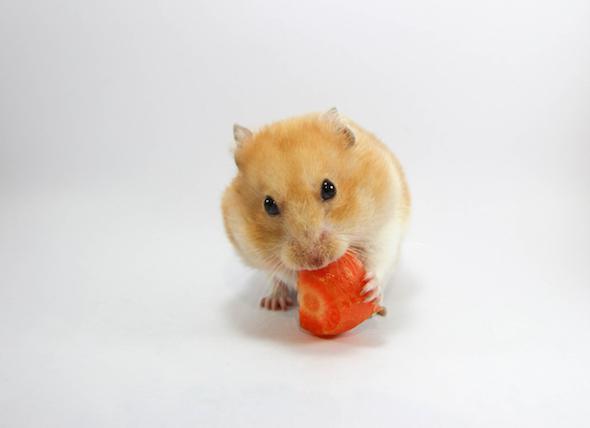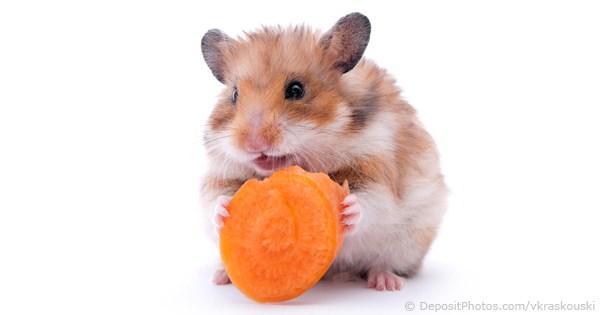The first image is the image on the left, the second image is the image on the right. Analyze the images presented: Is the assertion "The animal in the left image is eating an orange food" valid? Answer yes or no. Yes. The first image is the image on the left, the second image is the image on the right. For the images displayed, is the sentence "A hamster is eating broccoli on a white floor" factually correct? Answer yes or no. No. The first image is the image on the left, the second image is the image on the right. Assess this claim about the two images: "A rodent is busy munching on a piece of broccoli.". Correct or not? Answer yes or no. No. The first image is the image on the left, the second image is the image on the right. Assess this claim about the two images: "All of the hamsters are eating.". Correct or not? Answer yes or no. Yes. 